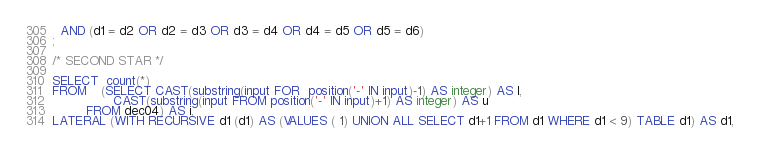Convert code to text. <code><loc_0><loc_0><loc_500><loc_500><_SQL_>  AND (d1 = d2 OR d2 = d3 OR d3 = d4 OR d4 = d5 OR d5 = d6)
;

/* SECOND STAR */

SELECT  count(*)
FROM    (SELECT CAST(substring(input FOR  position('-' IN input)-1) AS integer) AS l,
                CAST(substring(input FROM position('-' IN input)+1) AS integer) AS u
         FROM dec04) AS i,
LATERAL (WITH RECURSIVE d1 (d1) AS (VALUES ( 1) UNION ALL SELECT d1+1 FROM d1 WHERE d1 < 9) TABLE d1) AS d1,</code> 